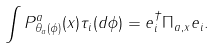Convert formula to latex. <formula><loc_0><loc_0><loc_500><loc_500>\int P _ { \theta _ { a } ( \phi ) } ^ { a } ( x ) \tau _ { i } ( d \phi ) = e _ { i } ^ { \dagger } \Pi _ { a , x } e _ { i } .</formula> 